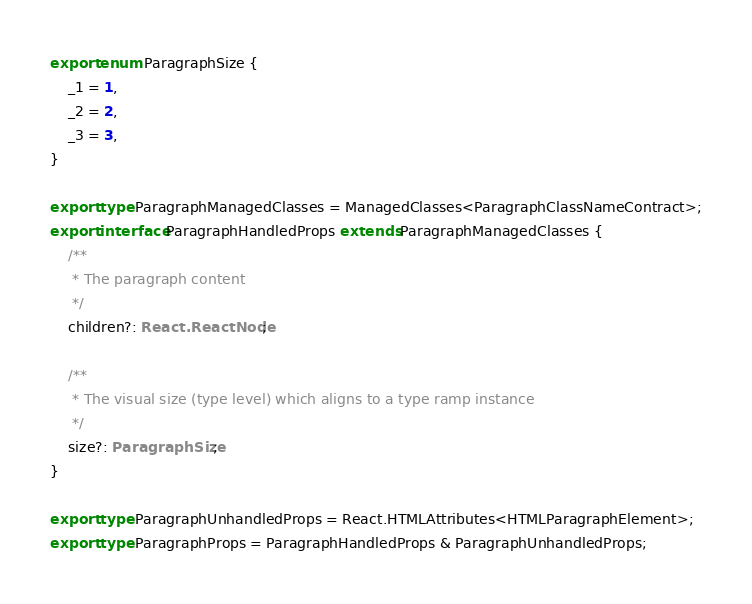<code> <loc_0><loc_0><loc_500><loc_500><_TypeScript_>export enum ParagraphSize {
    _1 = 1,
    _2 = 2,
    _3 = 3,
}

export type ParagraphManagedClasses = ManagedClasses<ParagraphClassNameContract>;
export interface ParagraphHandledProps extends ParagraphManagedClasses {
    /**
     * The paragraph content
     */
    children?: React.ReactNode;

    /**
     * The visual size (type level) which aligns to a type ramp instance
     */
    size?: ParagraphSize;
}

export type ParagraphUnhandledProps = React.HTMLAttributes<HTMLParagraphElement>;
export type ParagraphProps = ParagraphHandledProps & ParagraphUnhandledProps;
</code> 